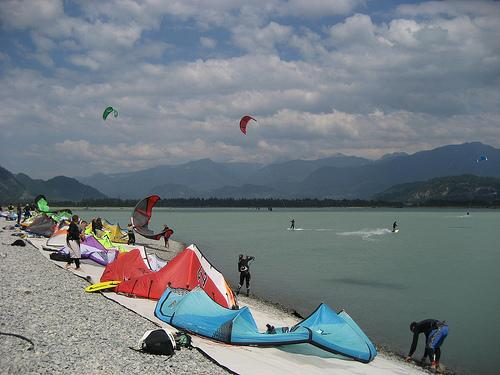Mention the essential components of the image in a single sentence. Kite surfers, wind surfers, colorful kites, and a mountainous backdrop define the image. Use vivid language to describe the key elements and actions in the image. Thrilling kite and wind surfers gracefully navigate the sparkling blue waters, surrounded by a symphony of vibrant kites and a backdrop of misty mountains. Describe the atmosphere of the image in a single sentence. An exhilarating day at the beach, filled with kite and wind surfers amidst an array of vibrant kites and a striking mountain view. Briefly narrate the actions occurring in the image. Kite surfers and wind surfers are skillfully maneuvering on the water as numerous colorful kites adorn the sky and beach, all set against a mountainous backdrop. Describe the main colors, elements, and activities represented in the image. The image features various bright-colored kites at the sky and ground near the beach, people actively engaged in wind and kite surfing, and a contrasting serene mountain range in the distance. Write a brief report of the primary scene presented in the image. The image showcases a beach scene where various individuals engage in kite and wind surfing, with colorful kites scattered across the sky and beach, and a mountainous background. List the essential elements of the scenery in the image. Kite surfers, wind surfers, colorful kites in the sky and on the ground, mountains in the background, people on the beach, and water splashes. Explain the main subject and what they are doing in the image. People enjoying water sports such as kite and wind surfing are the main subject, whilst surrounded by a plethora of colorful kites and a scenic mountainous backdrop. Provide a brief description of the primary activities and objects seen in this image. People are kite surfing and wind surfing, with various kites in the sky and on the ground, and mountains in the background. Write a concise summary of the most significant elements in the image. Kite and wind surfers enjoy the water, as colorful kites fill the sky and lie on the beach, with a scenic mountain range behind. 